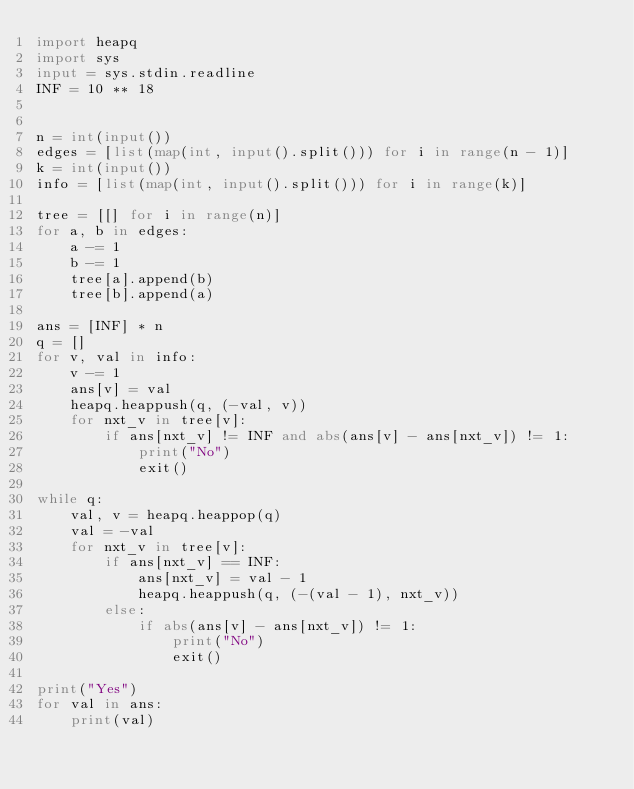Convert code to text. <code><loc_0><loc_0><loc_500><loc_500><_Python_>import heapq
import sys
input = sys.stdin.readline
INF = 10 ** 18


n = int(input())
edges = [list(map(int, input().split())) for i in range(n - 1)]
k = int(input())
info = [list(map(int, input().split())) for i in range(k)]

tree = [[] for i in range(n)]
for a, b in edges:
    a -= 1
    b -= 1
    tree[a].append(b)
    tree[b].append(a)

ans = [INF] * n
q = []
for v, val in info:
    v -= 1
    ans[v] = val
    heapq.heappush(q, (-val, v))
    for nxt_v in tree[v]:
        if ans[nxt_v] != INF and abs(ans[v] - ans[nxt_v]) != 1:
            print("No")
            exit()

while q:
    val, v = heapq.heappop(q)
    val = -val
    for nxt_v in tree[v]:
        if ans[nxt_v] == INF:
            ans[nxt_v] = val - 1
            heapq.heappush(q, (-(val - 1), nxt_v))
        else:
            if abs(ans[v] - ans[nxt_v]) != 1:
                print("No")
                exit()

print("Yes")
for val in ans:
    print(val)</code> 